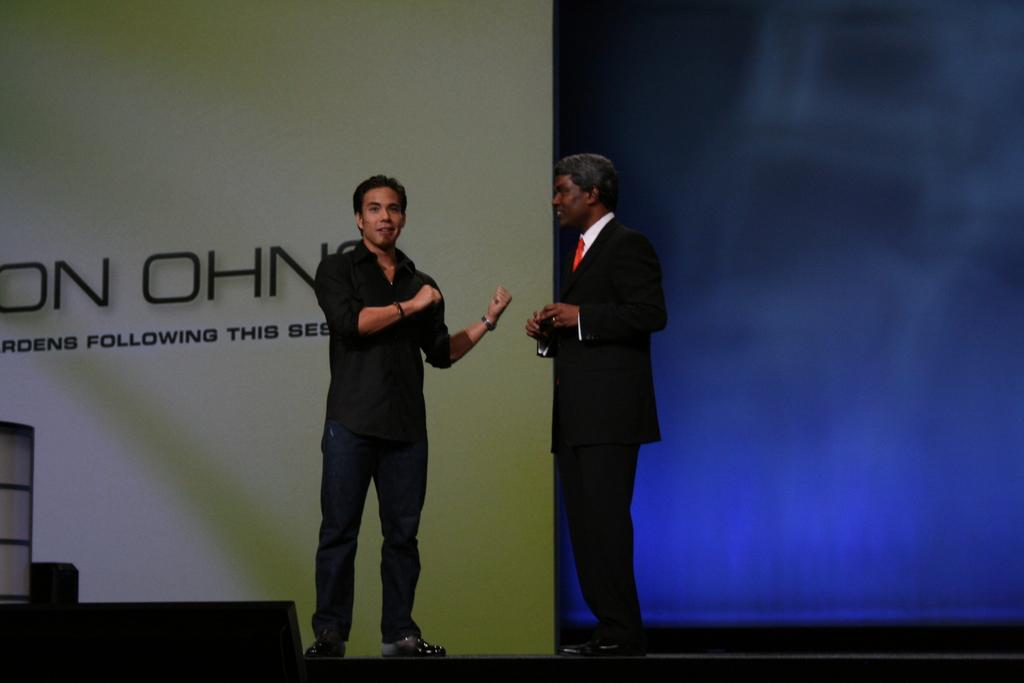How many people are in the image? There are two people in the image. What colors are the people wearing? The people are wearing black, red, and white color dresses. What can be seen in the background of the image? There is a board in the background of the image. What is the color of the background? The background of the image is blue. Can you see a tiger combing its fur in the image? No, there is no tiger or comb present in the image. 